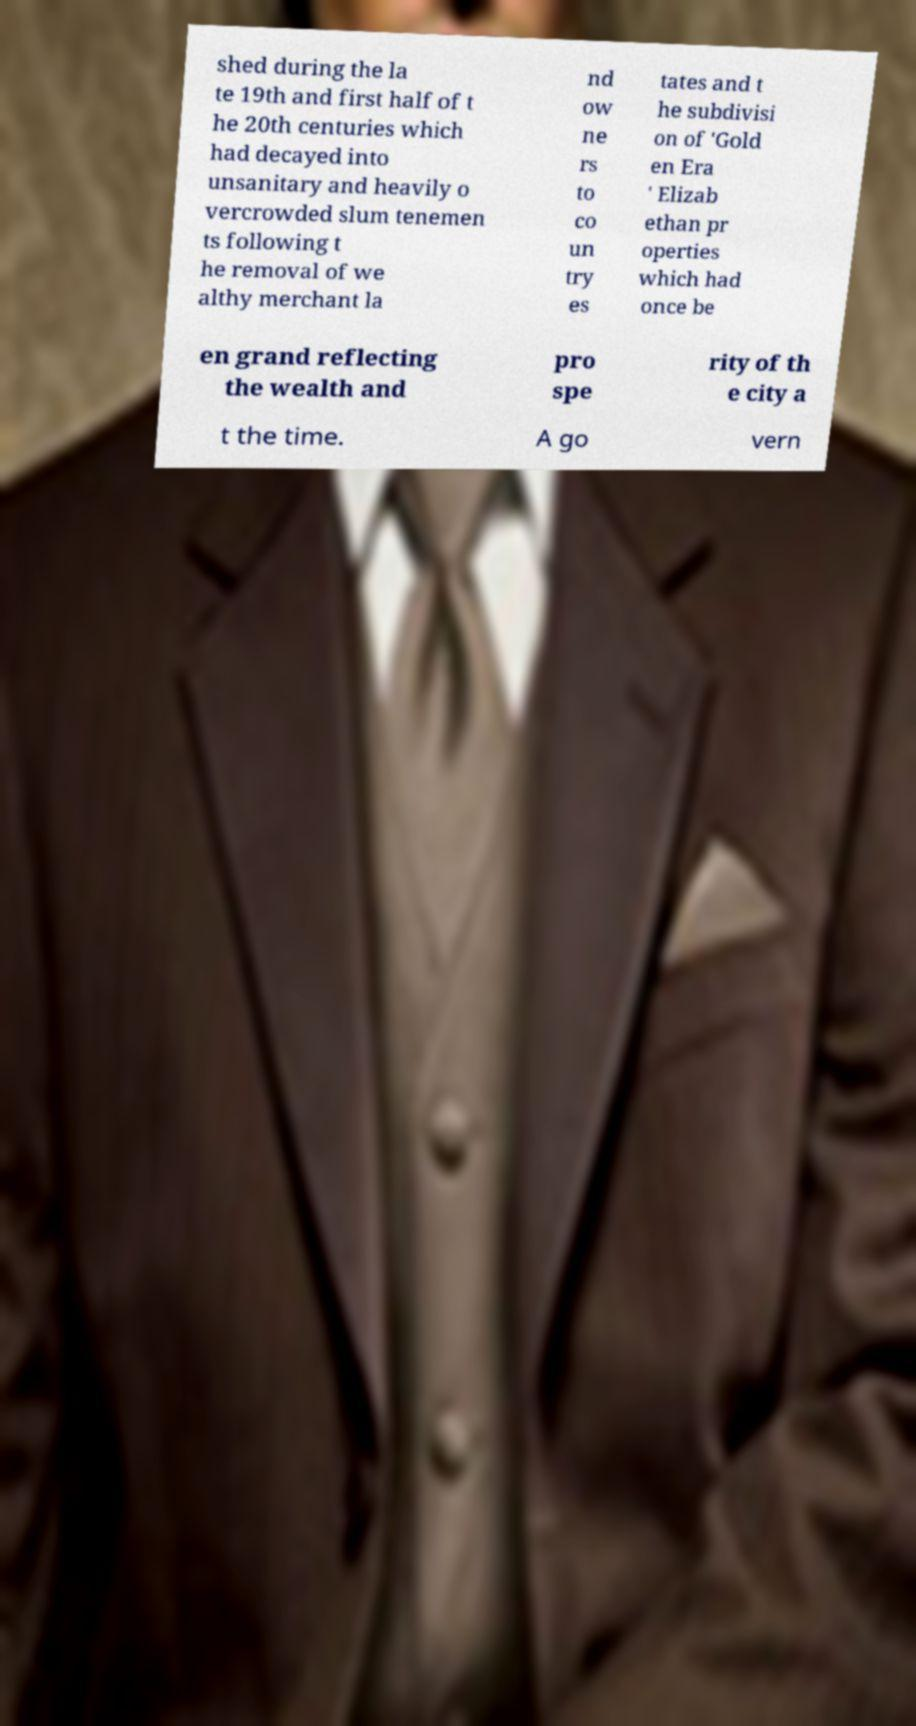I need the written content from this picture converted into text. Can you do that? shed during the la te 19th and first half of t he 20th centuries which had decayed into unsanitary and heavily o vercrowded slum tenemen ts following t he removal of we althy merchant la nd ow ne rs to co un try es tates and t he subdivisi on of 'Gold en Era ' Elizab ethan pr operties which had once be en grand reflecting the wealth and pro spe rity of th e city a t the time. A go vern 